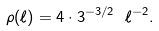Convert formula to latex. <formula><loc_0><loc_0><loc_500><loc_500>\rho ( \ell ) = 4 \cdot 3 ^ { - 3 / 2 } \ \ell ^ { - 2 } .</formula> 